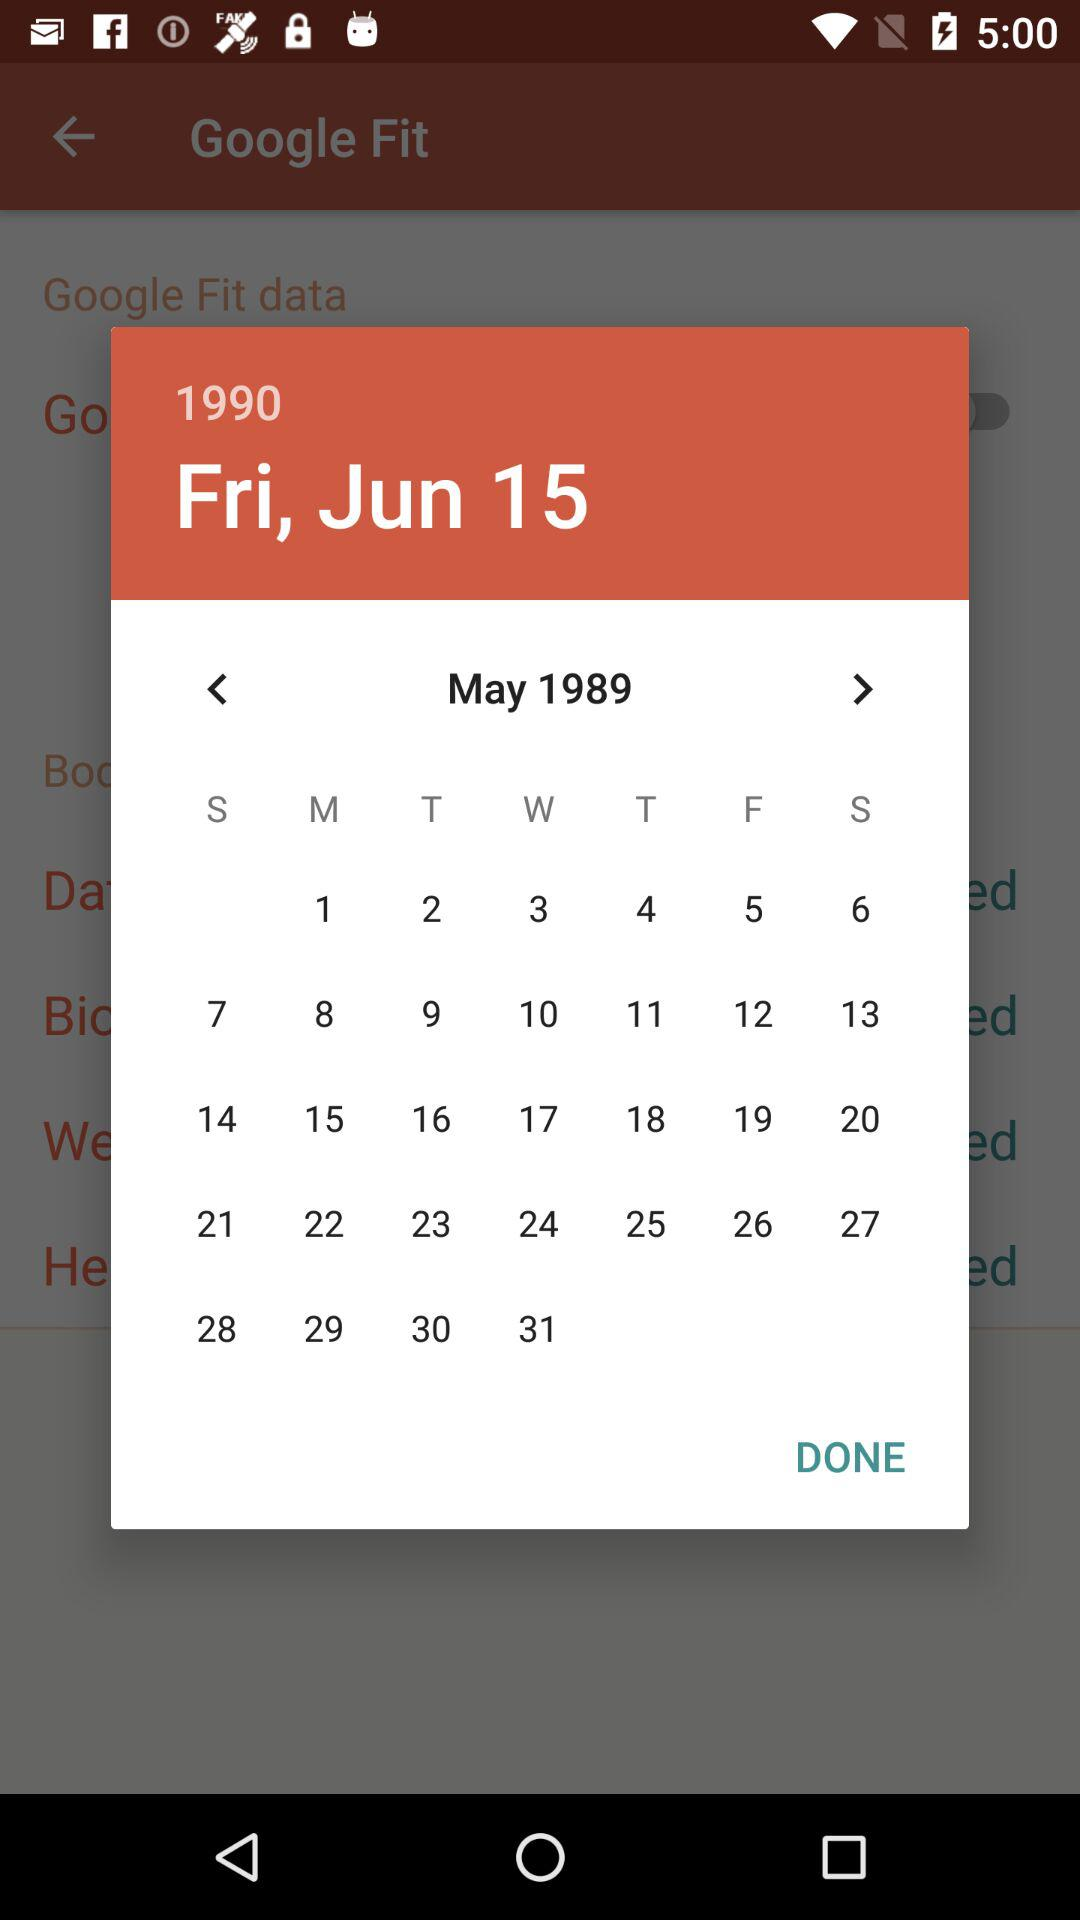What is the date? The date is Friday, 15 June 1990. 